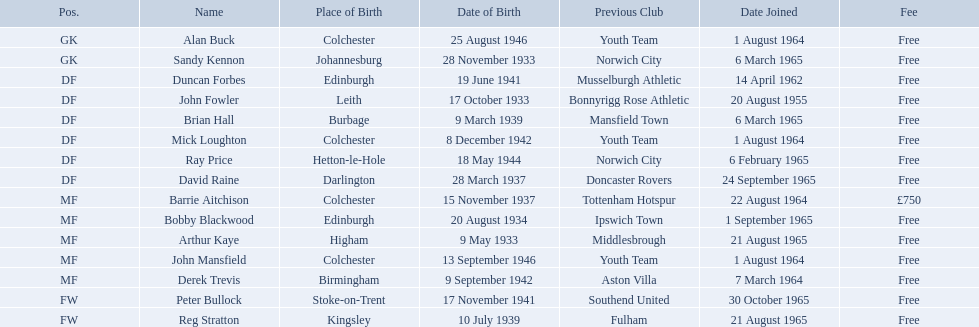When did each player join? 1 August 1964, 6 March 1965, 14 April 1962, 20 August 1955, 6 March 1965, 1 August 1964, 6 February 1965, 24 September 1965, 22 August 1964, 1 September 1965, 21 August 1965, 1 August 1964, 7 March 1964, 30 October 1965, 21 August 1965. And of those, which is the earliest join date? 20 August 1955. During the 1965-66 period, when did alan buck enter colchester united f.c.? 1 August 1964. When was the last player's joining? Peter Bullock. On which date did the premier player join? 20 August 1955. When did all the players sign up? 1 August 1964, 6 March 1965, 14 April 1962, 20 August 1955, 6 March 1965, 1 August 1964, 6 February 1965, 24 September 1965, 22 August 1964, 1 September 1965, 21 August 1965, 1 August 1964, 7 March 1964, 30 October 1965, 21 August 1965. From these, who has the earliest registration date? 20 August 1955. Can you name all the participants? Alan Buck, Sandy Kennon, Duncan Forbes, John Fowler, Brian Hall, Mick Loughton, Ray Price, David Raine, Barrie Aitchison, Bobby Blackwood, Arthur Kaye, John Mansfield, Derek Trevis, Peter Bullock, Reg Stratton. What are the respective joining dates for each player? 1 August 1964, 6 March 1965, 14 April 1962, 20 August 1955, 6 March 1965, 1 August 1964, 6 February 1965, 24 September 1965, 22 August 1964, 1 September 1965, 21 August 1965, 1 August 1964, 7 March 1964, 30 October 1965, 21 August 1965. Who joined the team first? John Fowler. On which date did the first player become a member? 20 August 1955. Who are the individuals participating? Alan Buck, Sandy Kennon, Duncan Forbes, John Fowler, Brian Hall, Mick Loughton, Ray Price, David Raine, Barrie Aitchison, Bobby Blackwood, Arthur Kaye, John Mansfield, Derek Trevis, Peter Bullock, Reg Stratton. What are the dates when each player joined? 1 August 1964, 6 March 1965, 14 April 1962, 20 August 1955, 6 March 1965, 1 August 1964, 6 February 1965, 24 September 1965, 22 August 1964, 1 September 1965, 21 August 1965, 1 August 1964, 7 March 1964, 30 October 1965, 21 August 1965. Who was the first to become a member? John Fowler. When did the first player join the group? 20 August 1955. Parse the table in full. {'header': ['Pos.', 'Name', 'Place of Birth', 'Date of Birth', 'Previous Club', 'Date Joined', 'Fee'], 'rows': [['GK', 'Alan Buck', 'Colchester', '25 August 1946', 'Youth Team', '1 August 1964', 'Free'], ['GK', 'Sandy Kennon', 'Johannesburg', '28 November 1933', 'Norwich City', '6 March 1965', 'Free'], ['DF', 'Duncan Forbes', 'Edinburgh', '19 June 1941', 'Musselburgh Athletic', '14 April 1962', 'Free'], ['DF', 'John Fowler', 'Leith', '17 October 1933', 'Bonnyrigg Rose Athletic', '20 August 1955', 'Free'], ['DF', 'Brian Hall', 'Burbage', '9 March 1939', 'Mansfield Town', '6 March 1965', 'Free'], ['DF', 'Mick Loughton', 'Colchester', '8 December 1942', 'Youth Team', '1 August 1964', 'Free'], ['DF', 'Ray Price', 'Hetton-le-Hole', '18 May 1944', 'Norwich City', '6 February 1965', 'Free'], ['DF', 'David Raine', 'Darlington', '28 March 1937', 'Doncaster Rovers', '24 September 1965', 'Free'], ['MF', 'Barrie Aitchison', 'Colchester', '15 November 1937', 'Tottenham Hotspur', '22 August 1964', '£750'], ['MF', 'Bobby Blackwood', 'Edinburgh', '20 August 1934', 'Ipswich Town', '1 September 1965', 'Free'], ['MF', 'Arthur Kaye', 'Higham', '9 May 1933', 'Middlesbrough', '21 August 1965', 'Free'], ['MF', 'John Mansfield', 'Colchester', '13 September 1946', 'Youth Team', '1 August 1964', 'Free'], ['MF', 'Derek Trevis', 'Birmingham', '9 September 1942', 'Aston Villa', '7 March 1964', 'Free'], ['FW', 'Peter Bullock', 'Stoke-on-Trent', '17 November 1941', 'Southend United', '30 October 1965', 'Free'], ['FW', 'Reg Stratton', 'Kingsley', '10 July 1939', 'Fulham', '21 August 1965', 'Free']]} At what point in time did every individual player become a member? 1 August 1964, 6 March 1965, 14 April 1962, 20 August 1955, 6 March 1965, 1 August 1964, 6 February 1965, 24 September 1965, 22 August 1964, 1 September 1965, 21 August 1965, 1 August 1964, 7 March 1964, 30 October 1965, 21 August 1965. Among them, who has the earliest membership date? 20 August 1955. 